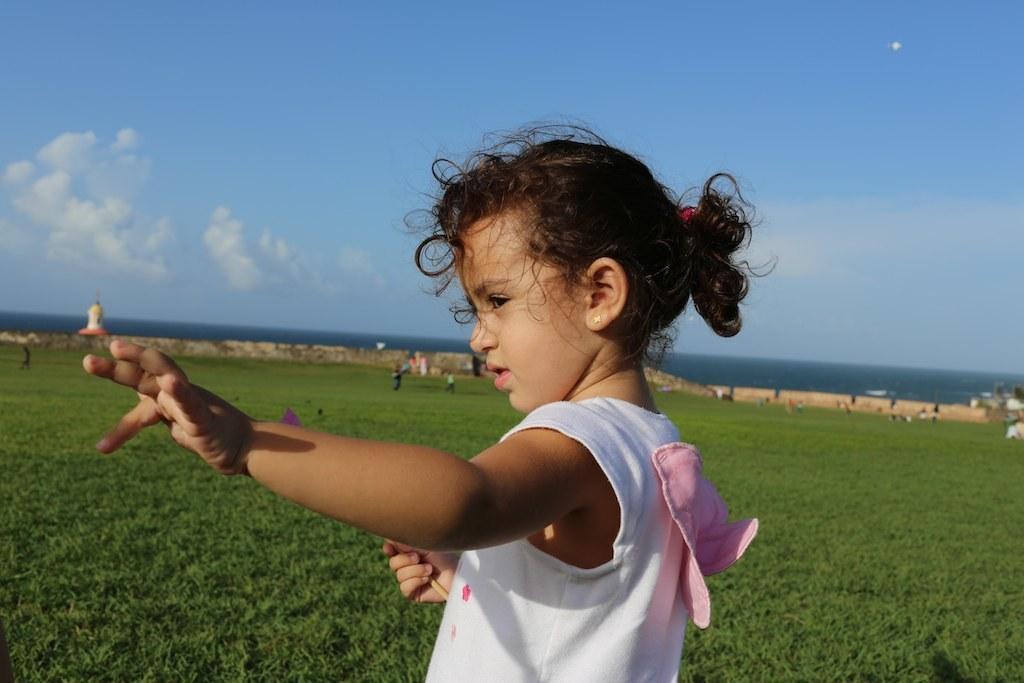In one or two sentences, can you explain what this image depicts? This picture is clicked outside. In the foreground there is a girl wearing white color t-shirt and standing. We can see the ground is covered with the green grass. In the background there is a sky and group of persons and some other objects. 